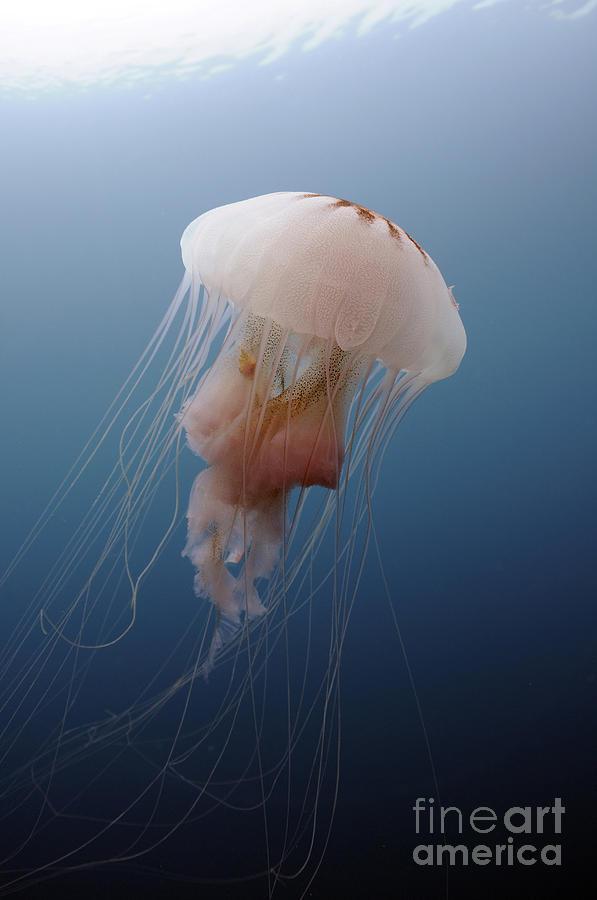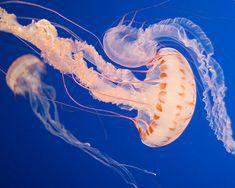The first image is the image on the left, the second image is the image on the right. Examine the images to the left and right. Is the description "The left image contains one jellyfish with a mushroom shaped cap facing rightside up and stringlike tentacles trailing down from it, and the right image includes a jellyfish with red-orange dots around the rim of its cap." accurate? Answer yes or no. Yes. 